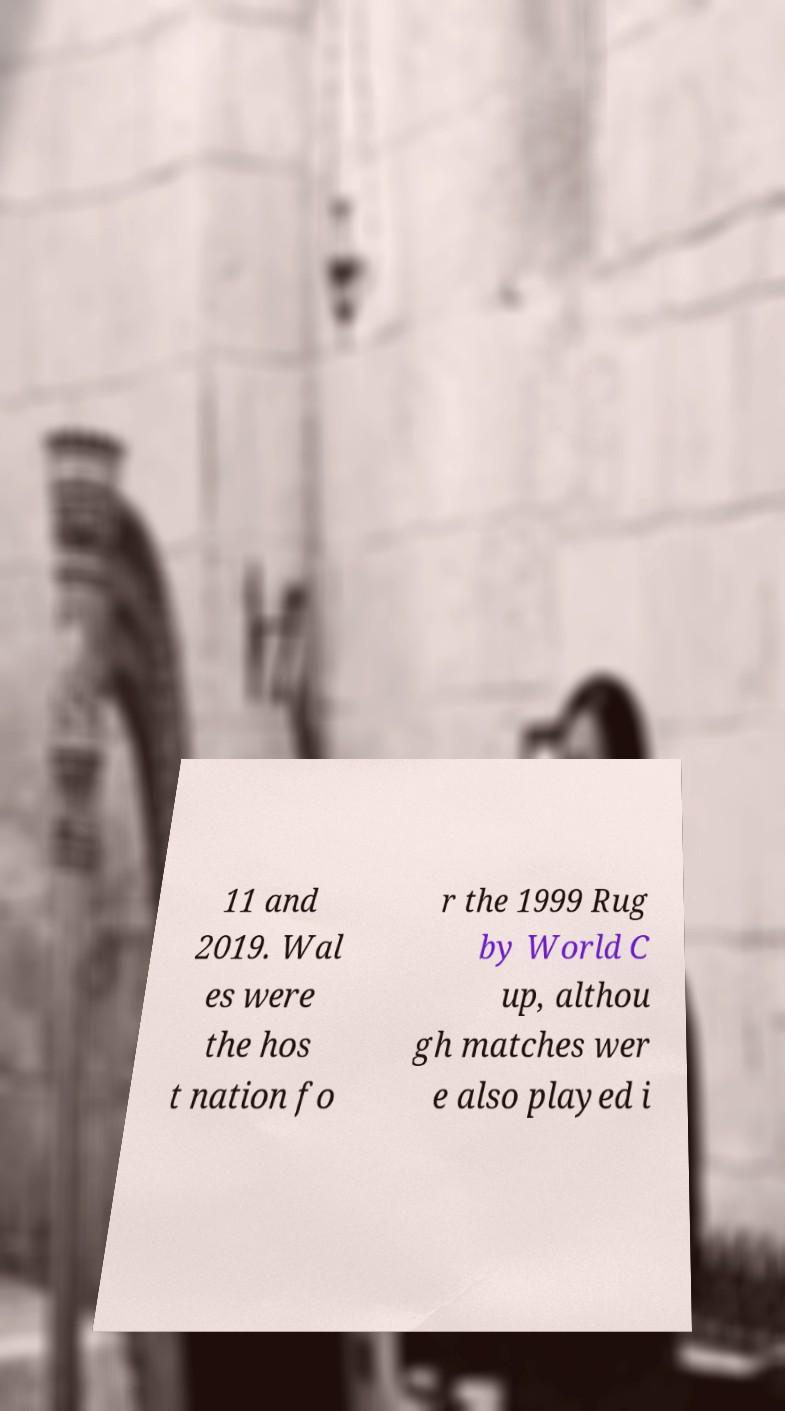Can you accurately transcribe the text from the provided image for me? 11 and 2019. Wal es were the hos t nation fo r the 1999 Rug by World C up, althou gh matches wer e also played i 